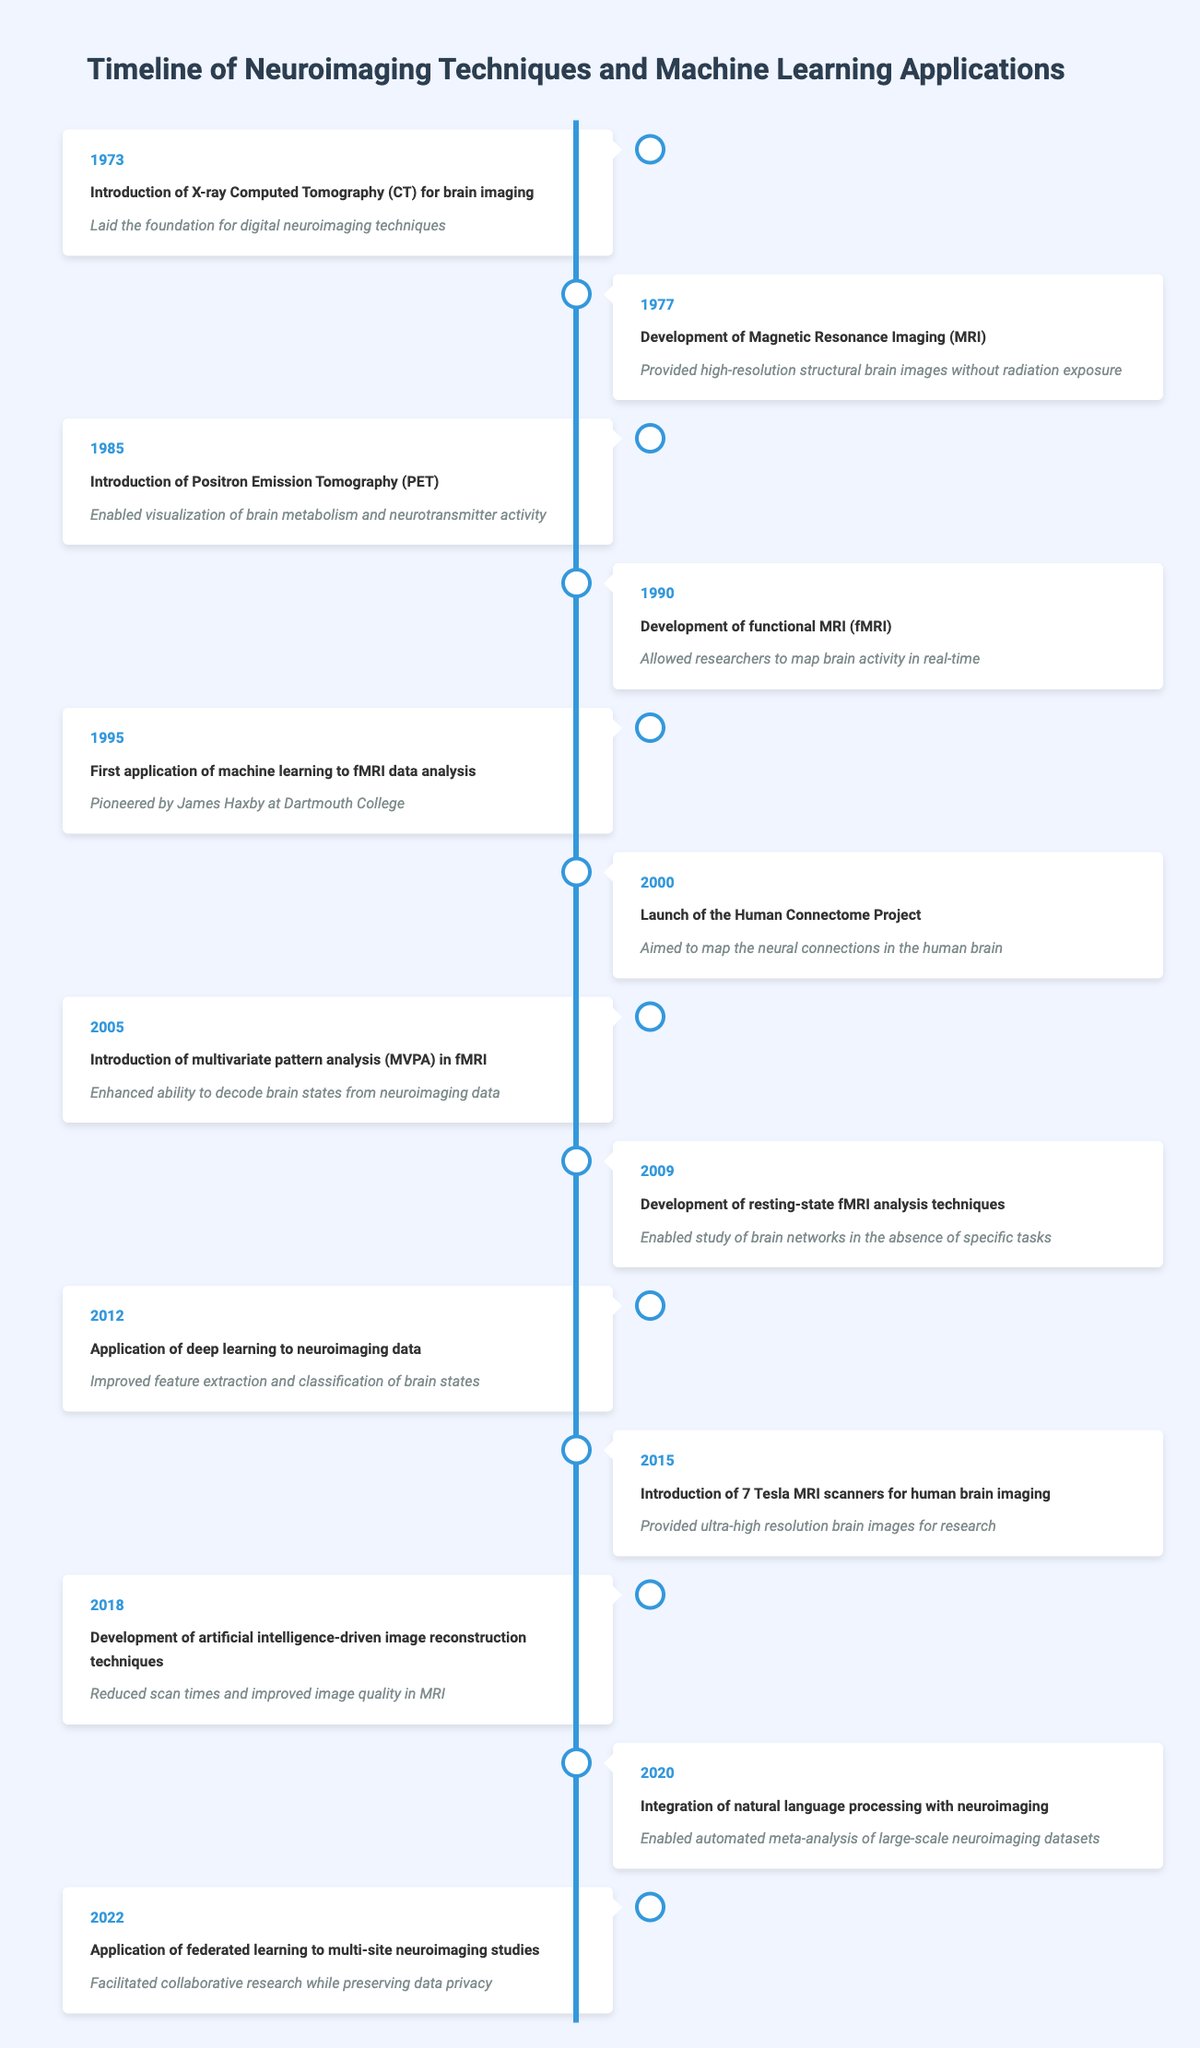What year was the first application of machine learning to fMRI data analysis? The table indicates that this event occurred in 1995. The corresponding entry lists both the year and the event clearly.
Answer: 1995 What is the significance of the introduction of 7 Tesla MRI scanners in 2015? The table states that the introduction of 7 Tesla MRI scanners "Provided ultra-high resolution brain images for research," which highlights its importance in advancing neuroimaging.
Answer: Provided ultra-high resolution brain images for research How many years passed between the development of MRI and the introduction of fMRI? The development of MRI happened in 1977 and fMRI was introduced in 1990. The difference in years is 1990 - 1977 = 13 years.
Answer: 13 years Was the Human Connectome Project launched after the introduction of deep learning to neuroimaging data? The table indicates the Human Connectome Project was launched in 2000 and deep learning was applied in 2012. Since 2000 is before 2012, the answer is no.
Answer: No How many neuroimaging techniques were introduced between 1973 and 2018? By reviewing the table, we identify that five major neuroimaging techniques were introduced: CT in 1973, MRI in 1977, PET in 1985, fMRI in 1990, and 7 Tesla MRI in 2015. Thus, the count is 5.
Answer: 5 techniques What was the significance of the application of federated learning in neuroimaging studies in 2022? The table states that the significance is "Facilitated collaborative research while preserving data privacy," which emphasizes the impact of this technique on research practices.
Answer: Facilitated collaborative research while preserving data privacy Which technique allowed real-time mapping of brain activity? The table states that functional MRI (fMRI) developed in 1990 "Allowed researchers to map brain activity in real-time." This directly indicates the technique responsible for this capability.
Answer: fMRI Was the introduction of X-ray Computed Tomography (CT) the first neuroimaging event listed in the table? According to the table, X-ray CT was introduced in 1973, and it is indeed the first event listed, confirming that this statement is true.
Answer: Yes What main advancement did the introduction of multivariate pattern analysis (MVPA) in 2005 contribute to neuroimaging data? The table shows that MVPA "Enhanced ability to decode brain states from neuroimaging data," indicating a key advancement in analysis techniques.
Answer: Enhanced ability to decode brain states from neuroimaging data 